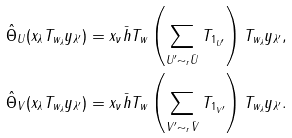Convert formula to latex. <formula><loc_0><loc_0><loc_500><loc_500>\hat { \Theta } _ { U } ( x _ { \lambda } T _ { w _ { \lambda } } y _ { \lambda ^ { \prime } } ) & = x _ { \nu } \bar { h } T _ { w } \left ( \sum _ { U ^ { \prime } \sim _ { r } \bar { U } } T _ { 1 _ { U ^ { \prime } } } \right ) T _ { w _ { \lambda } } y _ { \lambda ^ { \prime } } , \\ \hat { \Theta } _ { V } ( x _ { \lambda } T _ { w _ { \lambda } } y _ { \lambda ^ { \prime } } ) & = x _ { \nu } \bar { h } T _ { w } \left ( \sum _ { V ^ { \prime } \sim _ { r } \bar { V } } T _ { 1 _ { V ^ { \prime } } } \right ) T _ { w _ { \lambda } } y _ { \lambda ^ { \prime } } .</formula> 